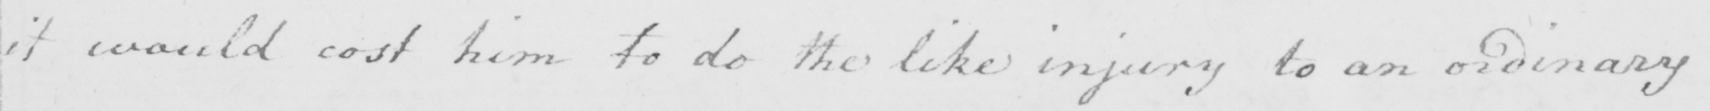What does this handwritten line say? it would cost him to do the like injury to an ordinary 